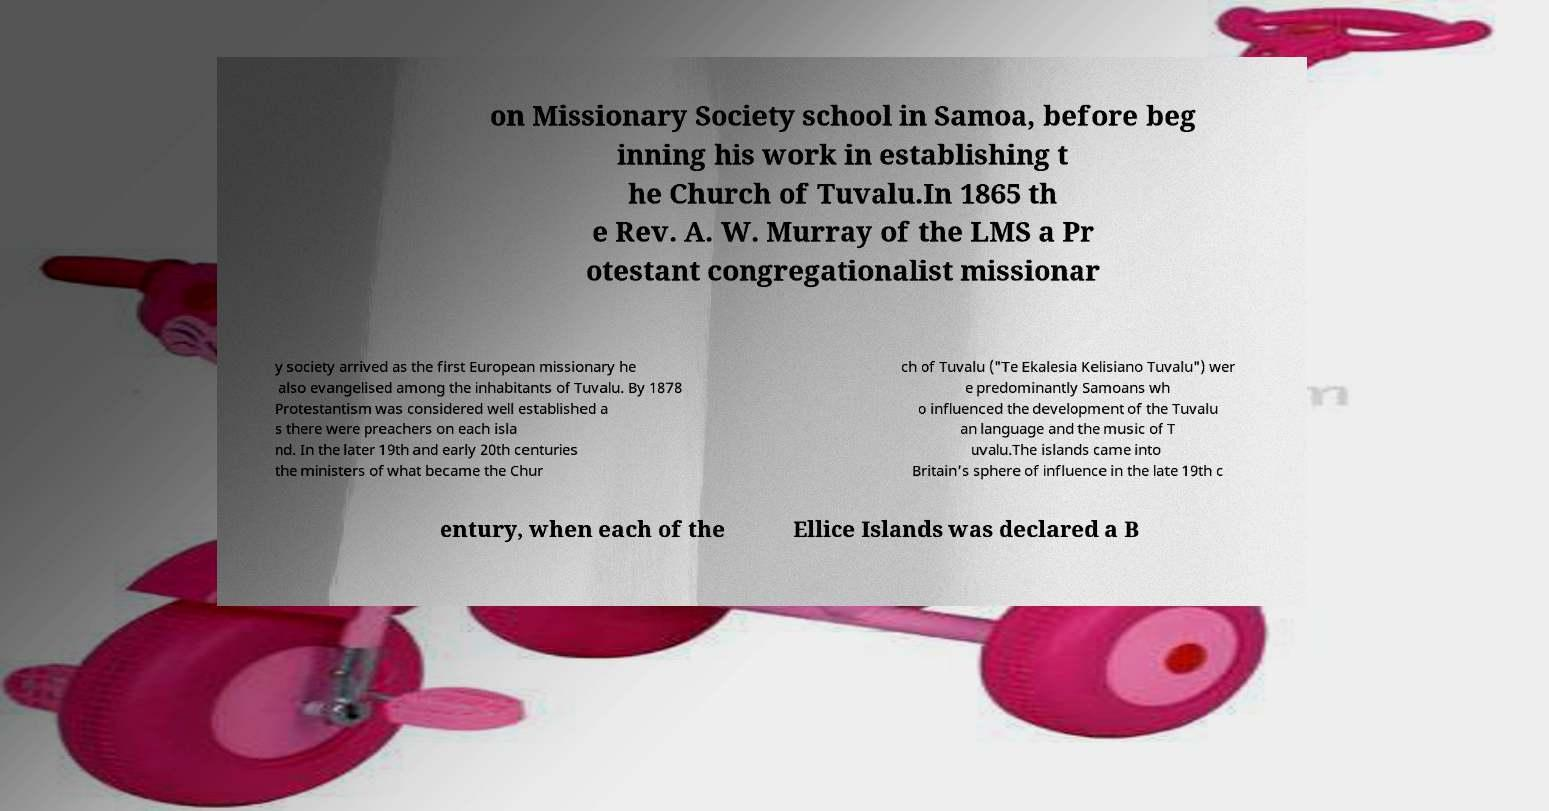Can you read and provide the text displayed in the image?This photo seems to have some interesting text. Can you extract and type it out for me? on Missionary Society school in Samoa, before beg inning his work in establishing t he Church of Tuvalu.In 1865 th e Rev. A. W. Murray of the LMS a Pr otestant congregationalist missionar y society arrived as the first European missionary he also evangelised among the inhabitants of Tuvalu. By 1878 Protestantism was considered well established a s there were preachers on each isla nd. In the later 19th and early 20th centuries the ministers of what became the Chur ch of Tuvalu ("Te Ekalesia Kelisiano Tuvalu") wer e predominantly Samoans wh o influenced the development of the Tuvalu an language and the music of T uvalu.The islands came into Britain's sphere of influence in the late 19th c entury, when each of the Ellice Islands was declared a B 